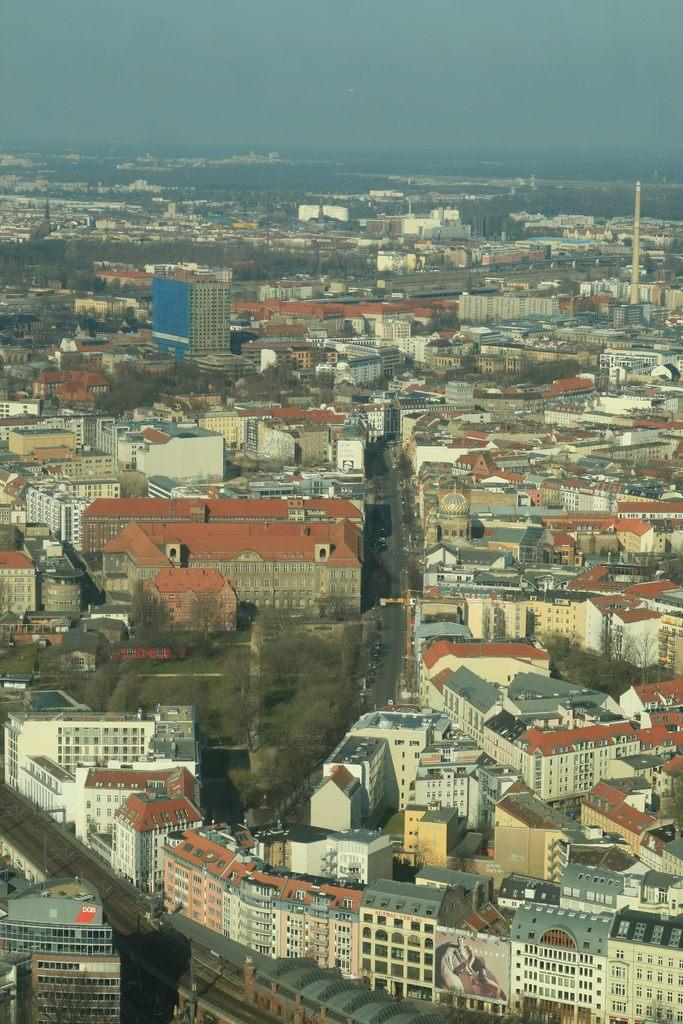What type of structures can be seen in the image? There are buildings in the image. What other natural elements are present in the image? There are trees in the image. What specific feature stands out among the buildings? There is a tower in the image. What is visible in the background of the image? The sky is visible in the image. What page of the book is the argument taking place on in the image? There is no book or argument present in the image; it features buildings, trees, a tower, and the sky. What type of town is depicted in the image? The image does not depict a town; it shows a scene with buildings, trees, a tower, and the sky. 